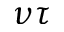Convert formula to latex. <formula><loc_0><loc_0><loc_500><loc_500>\nu \tau</formula> 